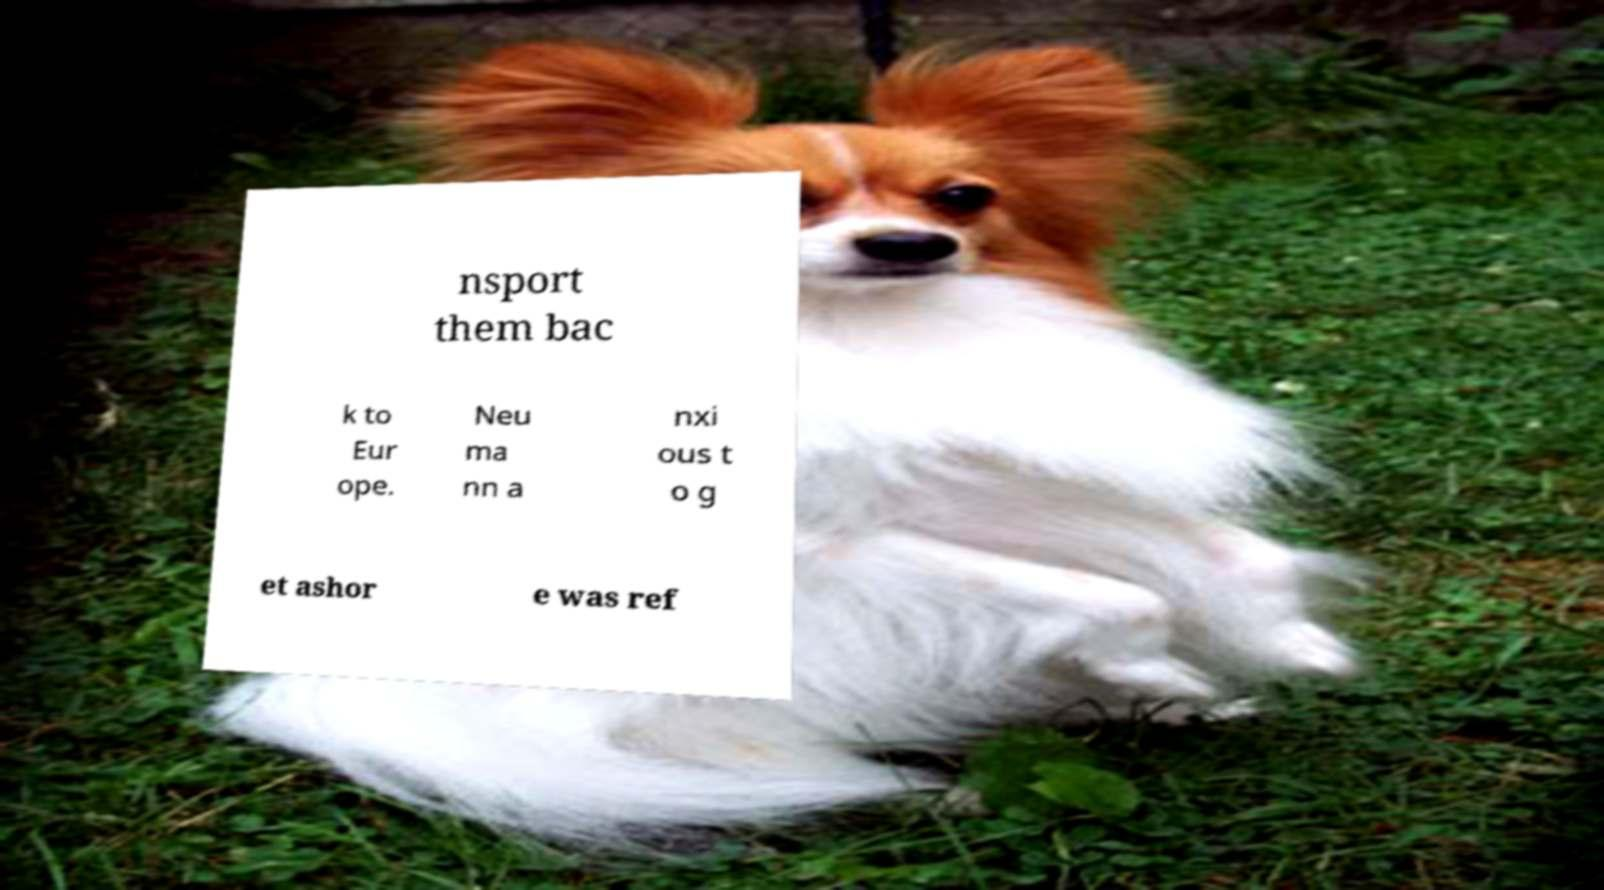For documentation purposes, I need the text within this image transcribed. Could you provide that? nsport them bac k to Eur ope. Neu ma nn a nxi ous t o g et ashor e was ref 